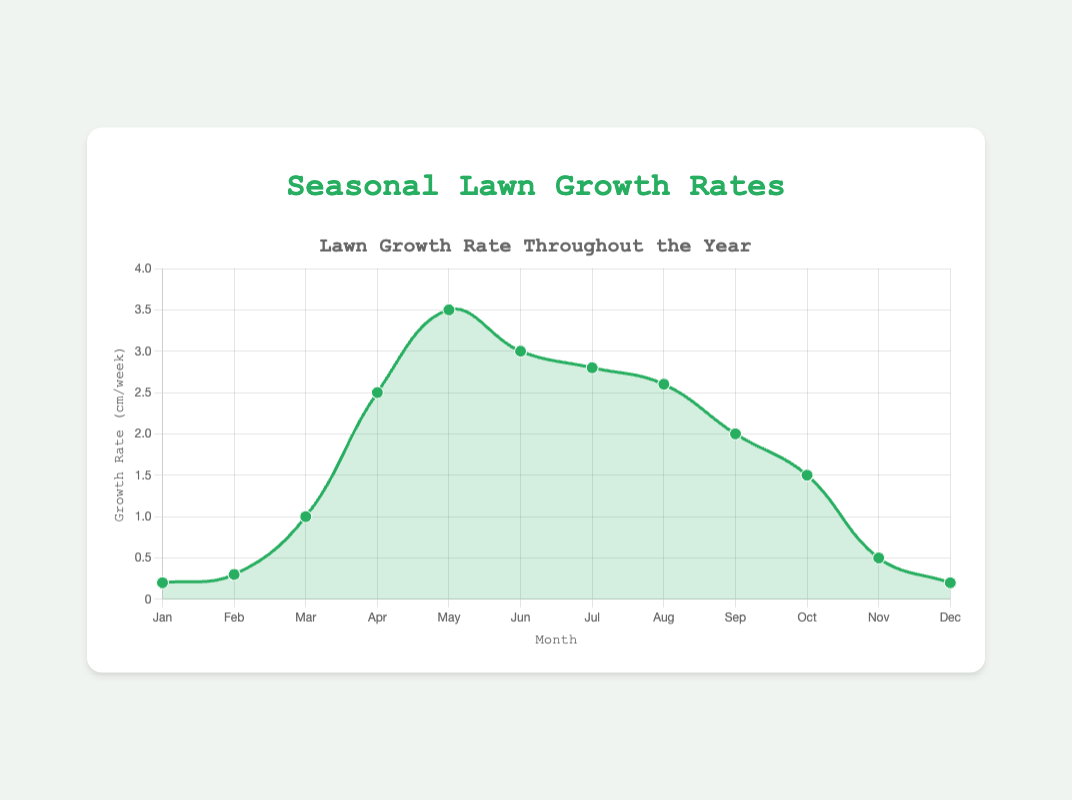What is the average growth rate in the first quarter of the year (January to March)? The growth rates for January, February, and March are 0.2, 0.3, and 1 cm/week respectively. Adding them results in 0.2 + 0.3 + 1 = 1.5, and dividing by 3 gives 1.5 / 3 = 0.5 cm/week.
Answer: 0.5 cm/week Which month has the highest lawn growth rate? The data shows that May has the highest lawn growth rate at 3.5 cm/week.
Answer: May What is the difference in growth rate between the peak month and the month with the lowest growth rate? The peak month is May with a growth rate of 3.5 cm/week, and the lowest growth rates are in January and December at 0.2 cm/week. The difference is 3.5 - 0.2 = 3.3 cm/week.
Answer: 3.3 cm/week How does the growth rate in April compare to that in July? April has a growth rate of 2.5 cm/week, and July has a growth rate of 2.8 cm/week. The growth rate in July is slightly higher than in April.
Answer: July's rate is higher What is the total growth for the summer months (June to August)? The growth rates for June, July, and August are 3, 2.8, and 2.6 cm/week respectively. The total growth is obtained by adding these values: 3 + 2.8 + 2.6 = 8.4 cm/week.
Answer: 8.4 cm/week Which month sees the most significant drop in growth rate compared to the previous month? The most significant drop is from June's 3 cm/week to July's 2.8 cm/week, which is a drop of 0.2 cm/week.
Answer: July By how much does the growth rate in September differ from that in October? September has a growth rate of 2 cm/week, while October's is 1.5 cm/week. The difference is 2 - 1.5 = 0.5 cm/week.
Answer: 0.5 cm/week Does the growth rate in April exceed that of November by more than twice? April's growth rate is 2.5 cm/week, and November's is 0.5 cm/week. Doubling November's rate gives 0.5 * 2 = 1. April's rate exceeds this by 2.5 - 1 = 1.5 cm/week, which is more than twice.
Answer: Yes What is the cumulative growth rate for the year by summing monthly growth rates? Summing all the monthly growth rates: 0.2 + 0.3 + 1 + 2.5 + 3.5 + 3 + 2.8 + 2.6 + 2 + 1.5 + 0.5 + 0.2 = 20.1 cm/week.
Answer: 20.1 cm/week 